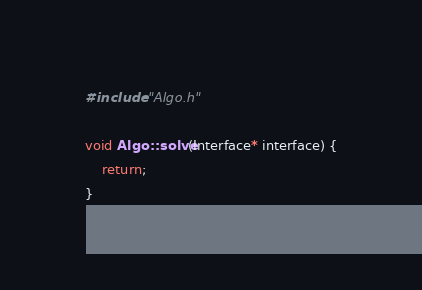Convert code to text. <code><loc_0><loc_0><loc_500><loc_500><_C++_>#include "Algo.h"

void Algo::solve(Interface* interface) {
    return;
}
</code> 